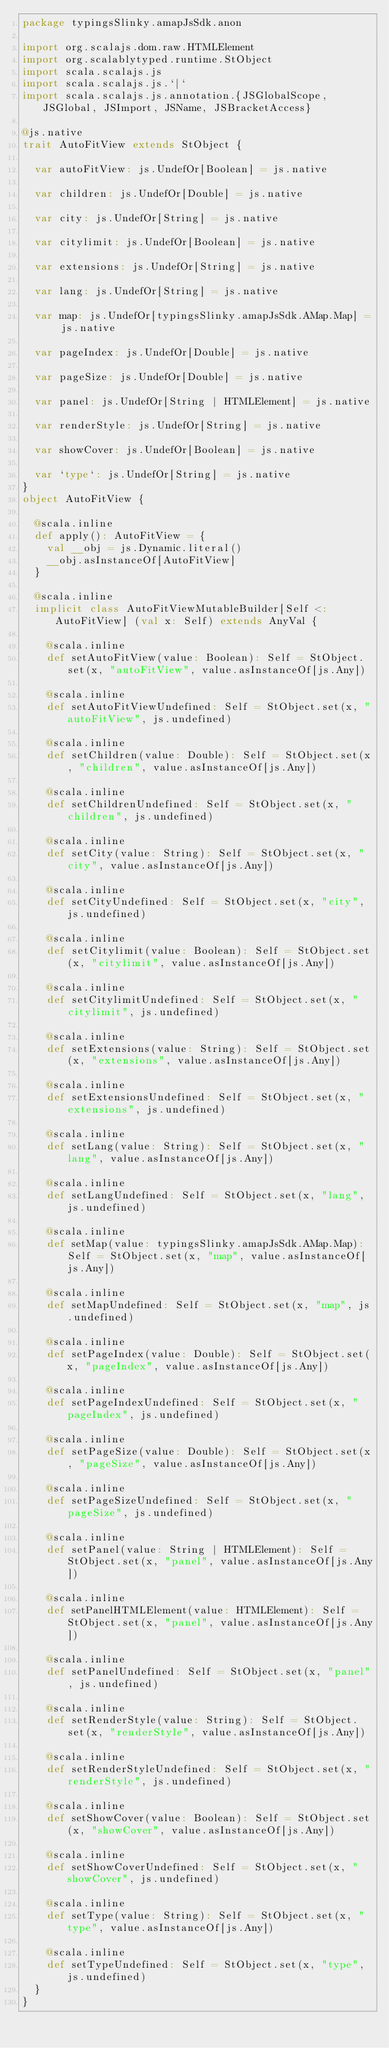Convert code to text. <code><loc_0><loc_0><loc_500><loc_500><_Scala_>package typingsSlinky.amapJsSdk.anon

import org.scalajs.dom.raw.HTMLElement
import org.scalablytyped.runtime.StObject
import scala.scalajs.js
import scala.scalajs.js.`|`
import scala.scalajs.js.annotation.{JSGlobalScope, JSGlobal, JSImport, JSName, JSBracketAccess}

@js.native
trait AutoFitView extends StObject {
  
  var autoFitView: js.UndefOr[Boolean] = js.native
  
  var children: js.UndefOr[Double] = js.native
  
  var city: js.UndefOr[String] = js.native
  
  var citylimit: js.UndefOr[Boolean] = js.native
  
  var extensions: js.UndefOr[String] = js.native
  
  var lang: js.UndefOr[String] = js.native
  
  var map: js.UndefOr[typingsSlinky.amapJsSdk.AMap.Map] = js.native
  
  var pageIndex: js.UndefOr[Double] = js.native
  
  var pageSize: js.UndefOr[Double] = js.native
  
  var panel: js.UndefOr[String | HTMLElement] = js.native
  
  var renderStyle: js.UndefOr[String] = js.native
  
  var showCover: js.UndefOr[Boolean] = js.native
  
  var `type`: js.UndefOr[String] = js.native
}
object AutoFitView {
  
  @scala.inline
  def apply(): AutoFitView = {
    val __obj = js.Dynamic.literal()
    __obj.asInstanceOf[AutoFitView]
  }
  
  @scala.inline
  implicit class AutoFitViewMutableBuilder[Self <: AutoFitView] (val x: Self) extends AnyVal {
    
    @scala.inline
    def setAutoFitView(value: Boolean): Self = StObject.set(x, "autoFitView", value.asInstanceOf[js.Any])
    
    @scala.inline
    def setAutoFitViewUndefined: Self = StObject.set(x, "autoFitView", js.undefined)
    
    @scala.inline
    def setChildren(value: Double): Self = StObject.set(x, "children", value.asInstanceOf[js.Any])
    
    @scala.inline
    def setChildrenUndefined: Self = StObject.set(x, "children", js.undefined)
    
    @scala.inline
    def setCity(value: String): Self = StObject.set(x, "city", value.asInstanceOf[js.Any])
    
    @scala.inline
    def setCityUndefined: Self = StObject.set(x, "city", js.undefined)
    
    @scala.inline
    def setCitylimit(value: Boolean): Self = StObject.set(x, "citylimit", value.asInstanceOf[js.Any])
    
    @scala.inline
    def setCitylimitUndefined: Self = StObject.set(x, "citylimit", js.undefined)
    
    @scala.inline
    def setExtensions(value: String): Self = StObject.set(x, "extensions", value.asInstanceOf[js.Any])
    
    @scala.inline
    def setExtensionsUndefined: Self = StObject.set(x, "extensions", js.undefined)
    
    @scala.inline
    def setLang(value: String): Self = StObject.set(x, "lang", value.asInstanceOf[js.Any])
    
    @scala.inline
    def setLangUndefined: Self = StObject.set(x, "lang", js.undefined)
    
    @scala.inline
    def setMap(value: typingsSlinky.amapJsSdk.AMap.Map): Self = StObject.set(x, "map", value.asInstanceOf[js.Any])
    
    @scala.inline
    def setMapUndefined: Self = StObject.set(x, "map", js.undefined)
    
    @scala.inline
    def setPageIndex(value: Double): Self = StObject.set(x, "pageIndex", value.asInstanceOf[js.Any])
    
    @scala.inline
    def setPageIndexUndefined: Self = StObject.set(x, "pageIndex", js.undefined)
    
    @scala.inline
    def setPageSize(value: Double): Self = StObject.set(x, "pageSize", value.asInstanceOf[js.Any])
    
    @scala.inline
    def setPageSizeUndefined: Self = StObject.set(x, "pageSize", js.undefined)
    
    @scala.inline
    def setPanel(value: String | HTMLElement): Self = StObject.set(x, "panel", value.asInstanceOf[js.Any])
    
    @scala.inline
    def setPanelHTMLElement(value: HTMLElement): Self = StObject.set(x, "panel", value.asInstanceOf[js.Any])
    
    @scala.inline
    def setPanelUndefined: Self = StObject.set(x, "panel", js.undefined)
    
    @scala.inline
    def setRenderStyle(value: String): Self = StObject.set(x, "renderStyle", value.asInstanceOf[js.Any])
    
    @scala.inline
    def setRenderStyleUndefined: Self = StObject.set(x, "renderStyle", js.undefined)
    
    @scala.inline
    def setShowCover(value: Boolean): Self = StObject.set(x, "showCover", value.asInstanceOf[js.Any])
    
    @scala.inline
    def setShowCoverUndefined: Self = StObject.set(x, "showCover", js.undefined)
    
    @scala.inline
    def setType(value: String): Self = StObject.set(x, "type", value.asInstanceOf[js.Any])
    
    @scala.inline
    def setTypeUndefined: Self = StObject.set(x, "type", js.undefined)
  }
}
</code> 